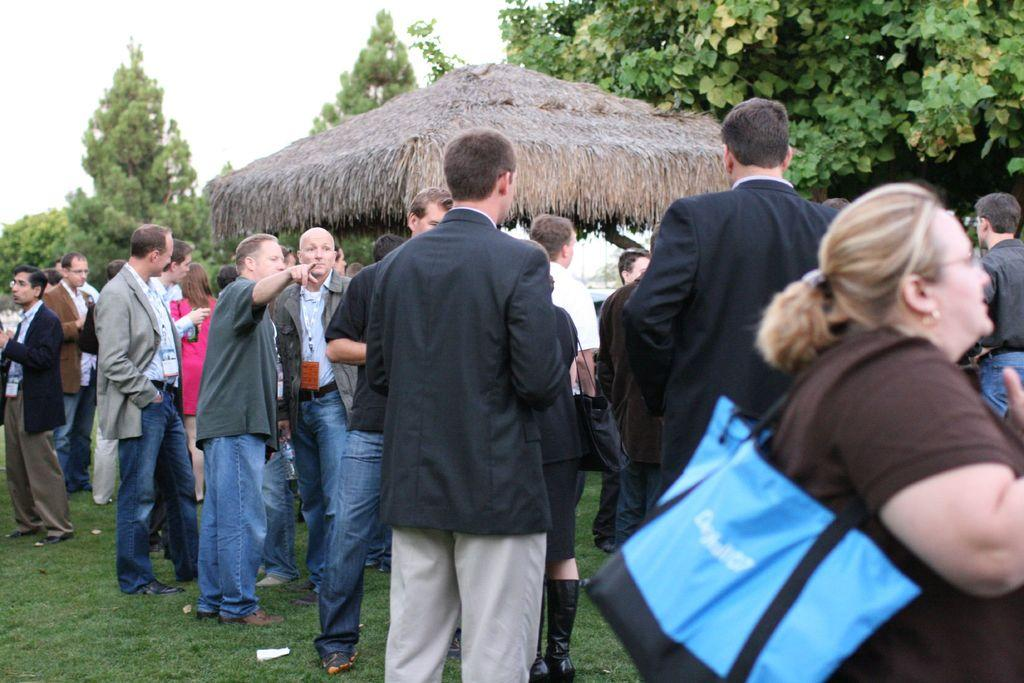Where was the image taken? The image was clicked outside. What can be seen in the background of the image? There are trees visible at the top of the image. What is the unclear object or feature in the middle of the image? There is an unclear object or feature in the middle of the image, referred to as "something like hit." How many people are present in the image? There are many people standing in the middle of the image. What type of sorting method are the people attempting to use in the image? There is no indication in the image that the people are attempting to use any sorting method. 